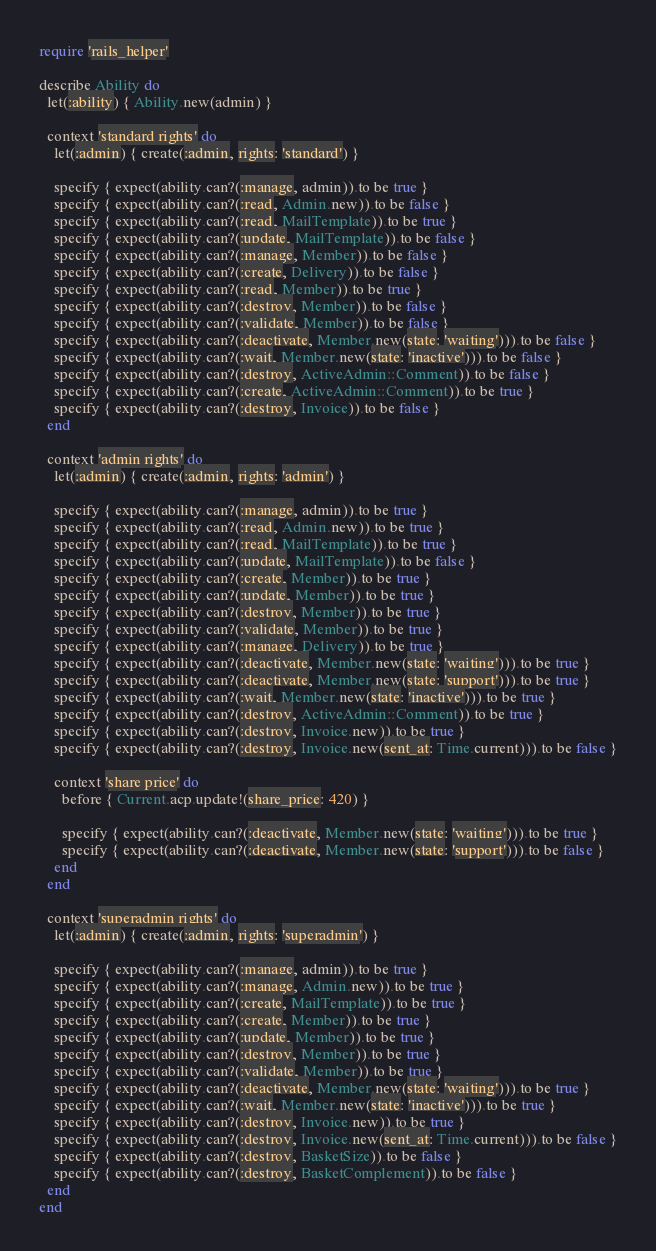Convert code to text. <code><loc_0><loc_0><loc_500><loc_500><_Ruby_>require 'rails_helper'

describe Ability do
  let(:ability) { Ability.new(admin) }

  context 'standard rights' do
    let(:admin) { create(:admin, rights: 'standard') }

    specify { expect(ability.can?(:manage, admin)).to be true }
    specify { expect(ability.can?(:read, Admin.new)).to be false }
    specify { expect(ability.can?(:read, MailTemplate)).to be true }
    specify { expect(ability.can?(:update, MailTemplate)).to be false }
    specify { expect(ability.can?(:manage, Member)).to be false }
    specify { expect(ability.can?(:create, Delivery)).to be false }
    specify { expect(ability.can?(:read, Member)).to be true }
    specify { expect(ability.can?(:destroy, Member)).to be false }
    specify { expect(ability.can?(:validate, Member)).to be false }
    specify { expect(ability.can?(:deactivate, Member.new(state: 'waiting'))).to be false }
    specify { expect(ability.can?(:wait, Member.new(state: 'inactive'))).to be false }
    specify { expect(ability.can?(:destroy, ActiveAdmin::Comment)).to be false }
    specify { expect(ability.can?(:create, ActiveAdmin::Comment)).to be true }
    specify { expect(ability.can?(:destroy, Invoice)).to be false }
  end

  context 'admin rights' do
    let(:admin) { create(:admin, rights: 'admin') }

    specify { expect(ability.can?(:manage, admin)).to be true }
    specify { expect(ability.can?(:read, Admin.new)).to be true }
    specify { expect(ability.can?(:read, MailTemplate)).to be true }
    specify { expect(ability.can?(:update, MailTemplate)).to be false }
    specify { expect(ability.can?(:create, Member)).to be true }
    specify { expect(ability.can?(:update, Member)).to be true }
    specify { expect(ability.can?(:destroy, Member)).to be true }
    specify { expect(ability.can?(:validate, Member)).to be true }
    specify { expect(ability.can?(:manage, Delivery)).to be true }
    specify { expect(ability.can?(:deactivate, Member.new(state: 'waiting'))).to be true }
    specify { expect(ability.can?(:deactivate, Member.new(state: 'support'))).to be true }
    specify { expect(ability.can?(:wait, Member.new(state: 'inactive'))).to be true }
    specify { expect(ability.can?(:destroy, ActiveAdmin::Comment)).to be true }
    specify { expect(ability.can?(:destroy, Invoice.new)).to be true }
    specify { expect(ability.can?(:destroy, Invoice.new(sent_at: Time.current))).to be false }

    context 'share price' do
      before { Current.acp.update!(share_price: 420) }

      specify { expect(ability.can?(:deactivate, Member.new(state: 'waiting'))).to be true }
      specify { expect(ability.can?(:deactivate, Member.new(state: 'support'))).to be false }
    end
  end

  context 'superadmin rights' do
    let(:admin) { create(:admin, rights: 'superadmin') }

    specify { expect(ability.can?(:manage, admin)).to be true }
    specify { expect(ability.can?(:manage, Admin.new)).to be true }
    specify { expect(ability.can?(:create, MailTemplate)).to be true }
    specify { expect(ability.can?(:create, Member)).to be true }
    specify { expect(ability.can?(:update, Member)).to be true }
    specify { expect(ability.can?(:destroy, Member)).to be true }
    specify { expect(ability.can?(:validate, Member)).to be true }
    specify { expect(ability.can?(:deactivate, Member.new(state: 'waiting'))).to be true }
    specify { expect(ability.can?(:wait, Member.new(state: 'inactive'))).to be true }
    specify { expect(ability.can?(:destroy, Invoice.new)).to be true }
    specify { expect(ability.can?(:destroy, Invoice.new(sent_at: Time.current))).to be false }
    specify { expect(ability.can?(:destroy, BasketSize)).to be false }
    specify { expect(ability.can?(:destroy, BasketComplement)).to be false }
  end
end
</code> 